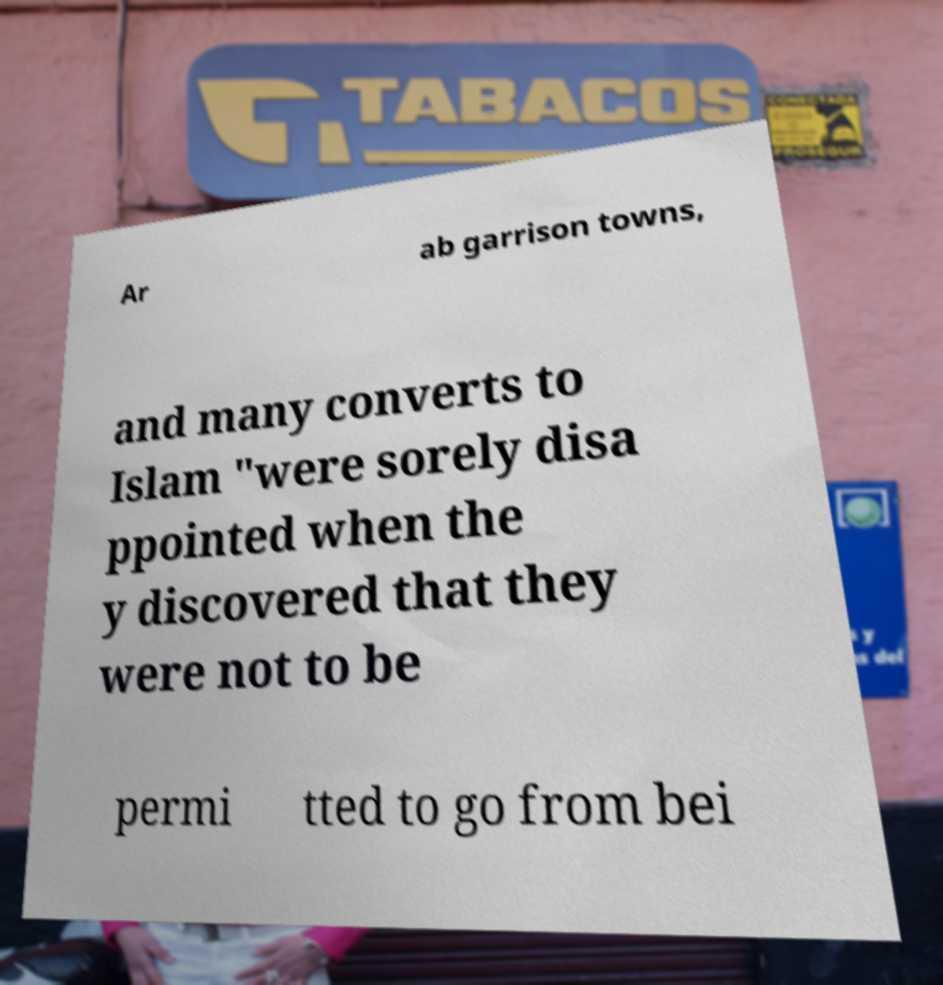I need the written content from this picture converted into text. Can you do that? Ar ab garrison towns, and many converts to Islam "were sorely disa ppointed when the y discovered that they were not to be permi tted to go from bei 